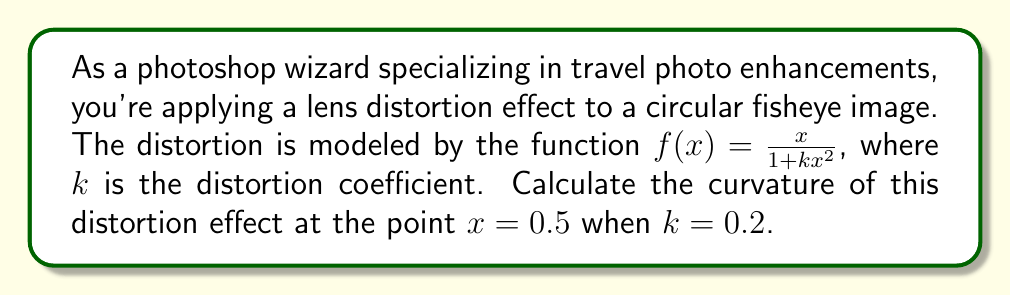Can you solve this math problem? To calculate the curvature of the lens distortion effect, we'll follow these steps:

1) The general formula for curvature is:

   $$\kappa = \frac{|f''(x)|}{(1 + (f'(x))^2)^{3/2}}$$

2) First, let's find $f'(x)$:
   
   $$f'(x) = \frac{(1 + kx^2) - x(2kx)}{(1 + kx^2)^2} = \frac{1 - kx^2}{(1 + kx^2)^2}$$

3) Now, let's find $f''(x)$:
   
   $$f''(x) = \frac{-2kx(1 + kx^2)^2 - (1 - kx^2)(4kx(1 + kx^2))}{(1 + kx^2)^4}$$
   
   $$= \frac{-2kx - 4kx + 4k^2x^3}{(1 + kx^2)^3} = \frac{-6kx + 4k^2x^3}{(1 + kx^2)^3}$$

4) Now, we substitute $x = 0.5$ and $k = 0.2$ into $f'(x)$:

   $$f'(0.5) = \frac{1 - 0.2(0.5)^2}{(1 + 0.2(0.5)^2)^2} = \frac{0.95}{1.1025^2} \approx 0.7811$$

5) We do the same for $f''(x)$:

   $$f''(0.5) = \frac{-6(0.2)(0.5) + 4(0.2)^2(0.5)^3}{(1 + 0.2(0.5)^2)^3} = \frac{-0.6 + 0.005}{1.1025^3} \approx -0.4455$$

6) Now we can substitute these values into the curvature formula:

   $$\kappa = \frac{|-0.4455|}{(1 + 0.7811^2)^{3/2}} \approx 0.2034$$

Therefore, the curvature of the lens distortion effect at $x = 0.5$ when $k = 0.2$ is approximately 0.2034.
Answer: 0.2034 